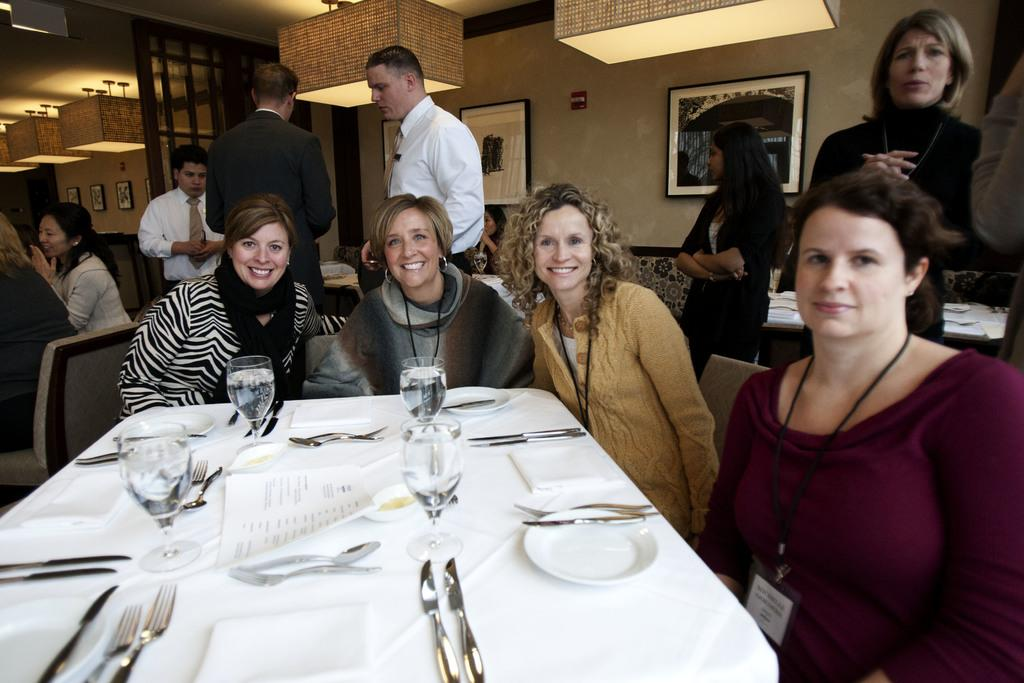What are the people in the image doing? The people in the image are sitting on chairs. What objects can be seen on the table in the image? There is a glass, a knife, and a fork on the table in the image. What is hanging on the wall in the image? There is a frame on the wall in the image. What source of illumination is present in the image? There is a light in the image. What type of cake is being served to the passengers in the image? There is no cake or passengers present in the image. 